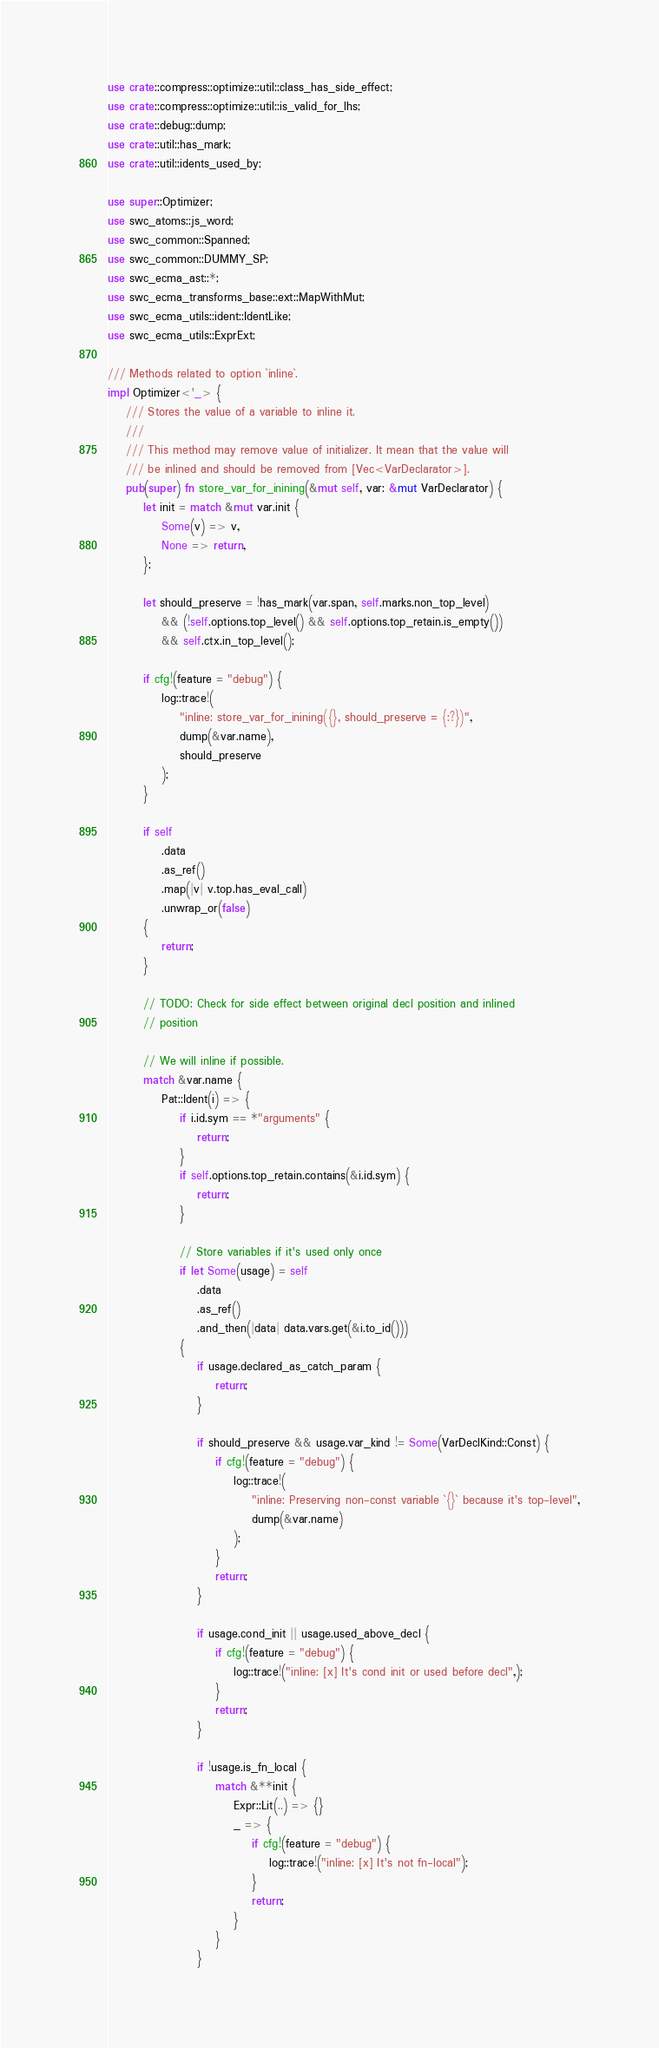<code> <loc_0><loc_0><loc_500><loc_500><_Rust_>use crate::compress::optimize::util::class_has_side_effect;
use crate::compress::optimize::util::is_valid_for_lhs;
use crate::debug::dump;
use crate::util::has_mark;
use crate::util::idents_used_by;

use super::Optimizer;
use swc_atoms::js_word;
use swc_common::Spanned;
use swc_common::DUMMY_SP;
use swc_ecma_ast::*;
use swc_ecma_transforms_base::ext::MapWithMut;
use swc_ecma_utils::ident::IdentLike;
use swc_ecma_utils::ExprExt;

/// Methods related to option `inline`.
impl Optimizer<'_> {
    /// Stores the value of a variable to inline it.
    ///
    /// This method may remove value of initializer. It mean that the value will
    /// be inlined and should be removed from [Vec<VarDeclarator>].
    pub(super) fn store_var_for_inining(&mut self, var: &mut VarDeclarator) {
        let init = match &mut var.init {
            Some(v) => v,
            None => return,
        };

        let should_preserve = !has_mark(var.span, self.marks.non_top_level)
            && (!self.options.top_level() && self.options.top_retain.is_empty())
            && self.ctx.in_top_level();

        if cfg!(feature = "debug") {
            log::trace!(
                "inline: store_var_for_inining({}, should_preserve = {:?})",
                dump(&var.name),
                should_preserve
            );
        }

        if self
            .data
            .as_ref()
            .map(|v| v.top.has_eval_call)
            .unwrap_or(false)
        {
            return;
        }

        // TODO: Check for side effect between original decl position and inlined
        // position

        // We will inline if possible.
        match &var.name {
            Pat::Ident(i) => {
                if i.id.sym == *"arguments" {
                    return;
                }
                if self.options.top_retain.contains(&i.id.sym) {
                    return;
                }

                // Store variables if it's used only once
                if let Some(usage) = self
                    .data
                    .as_ref()
                    .and_then(|data| data.vars.get(&i.to_id()))
                {
                    if usage.declared_as_catch_param {
                        return;
                    }

                    if should_preserve && usage.var_kind != Some(VarDeclKind::Const) {
                        if cfg!(feature = "debug") {
                            log::trace!(
                                "inline: Preserving non-const variable `{}` because it's top-level",
                                dump(&var.name)
                            );
                        }
                        return;
                    }

                    if usage.cond_init || usage.used_above_decl {
                        if cfg!(feature = "debug") {
                            log::trace!("inline: [x] It's cond init or used before decl",);
                        }
                        return;
                    }

                    if !usage.is_fn_local {
                        match &**init {
                            Expr::Lit(..) => {}
                            _ => {
                                if cfg!(feature = "debug") {
                                    log::trace!("inline: [x] It's not fn-local");
                                }
                                return;
                            }
                        }
                    }
</code> 